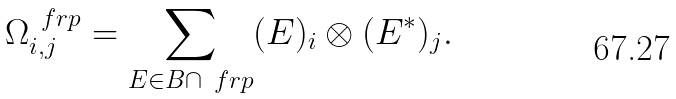<formula> <loc_0><loc_0><loc_500><loc_500>\Omega _ { i , j } ^ { \ f r p } = \sum _ { E \in B \cap \ f r p } ( E ) _ { i } \otimes ( E ^ { * } ) _ { j } .</formula> 